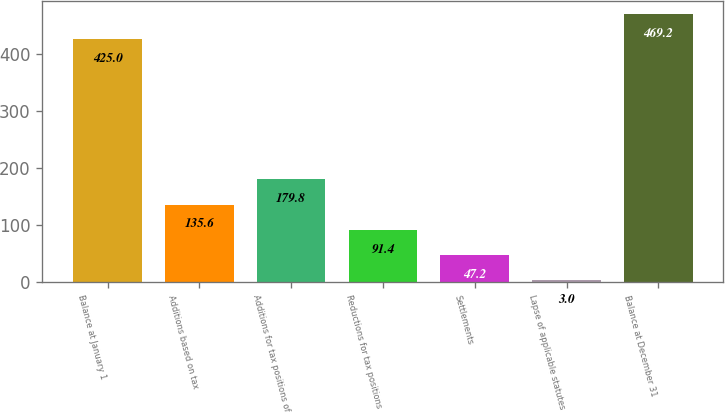Convert chart to OTSL. <chart><loc_0><loc_0><loc_500><loc_500><bar_chart><fcel>Balance at January 1<fcel>Additions based on tax<fcel>Additions for tax positions of<fcel>Reductions for tax positions<fcel>Settlements<fcel>Lapse of applicable statutes<fcel>Balance at December 31<nl><fcel>425<fcel>135.6<fcel>179.8<fcel>91.4<fcel>47.2<fcel>3<fcel>469.2<nl></chart> 